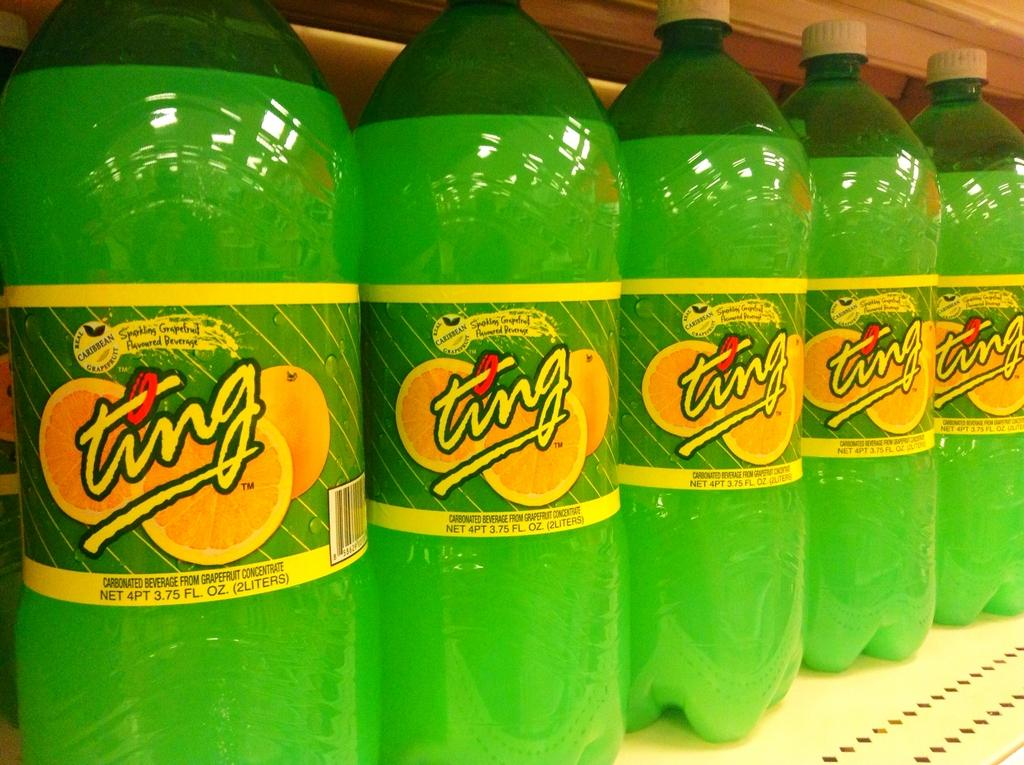<image>
Provide a brief description of the given image. several bottles of Ting lemon drink on a shelf 